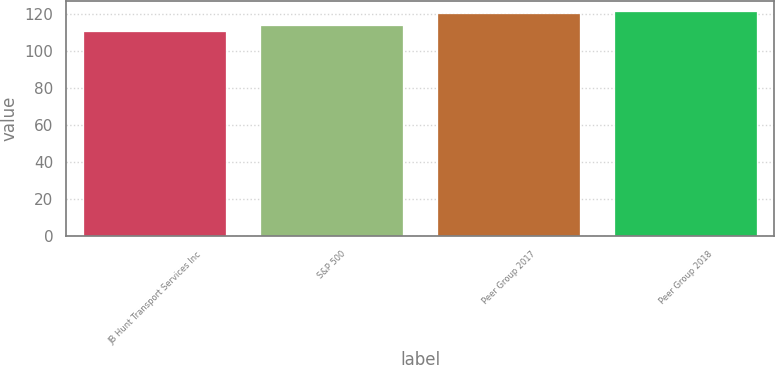<chart> <loc_0><loc_0><loc_500><loc_500><bar_chart><fcel>JB Hunt Transport Services Inc<fcel>S&P 500<fcel>Peer Group 2017<fcel>Peer Group 2018<nl><fcel>110.12<fcel>113.69<fcel>120.17<fcel>121.25<nl></chart> 